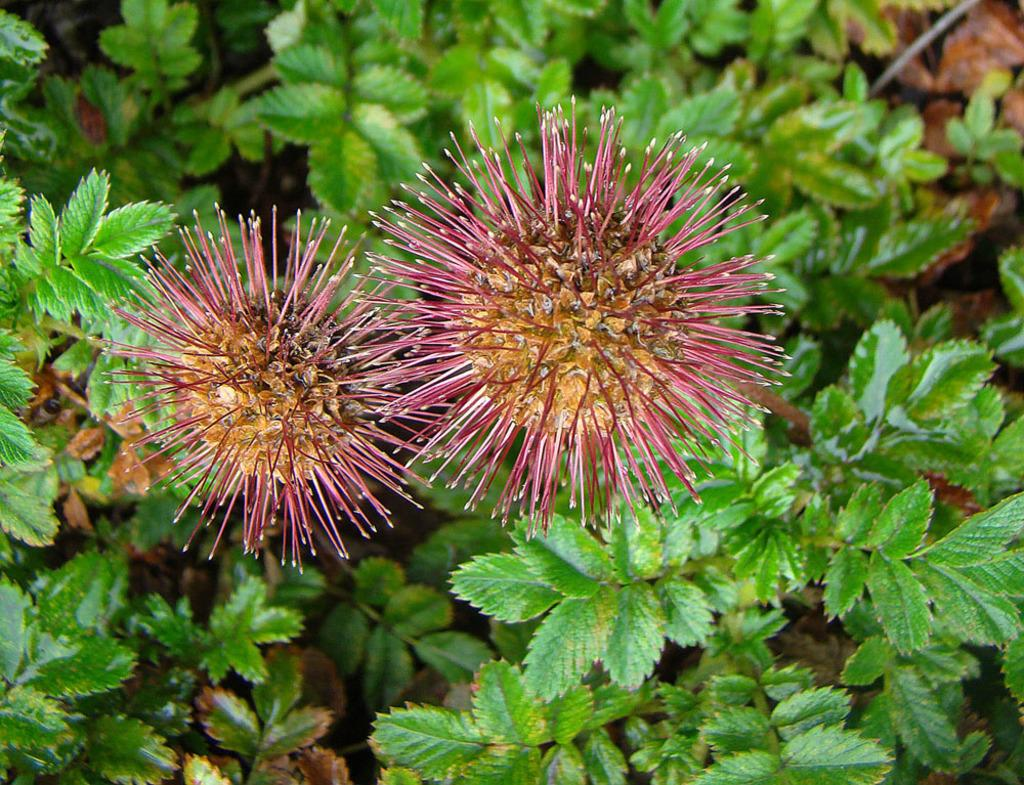What is the main subject of the image? The main subject of the image is a bottlebrush plant. Can you describe the view of the image? The image is a zoomed-in view of the plant. What is the purpose of the quilt in the image? There is no quilt present in the image; the main subject is a bottlebrush plant. What type of pot is the plant in within the image? The image is a zoomed-in view of the plant, so it does not show the pot or any surrounding context. 